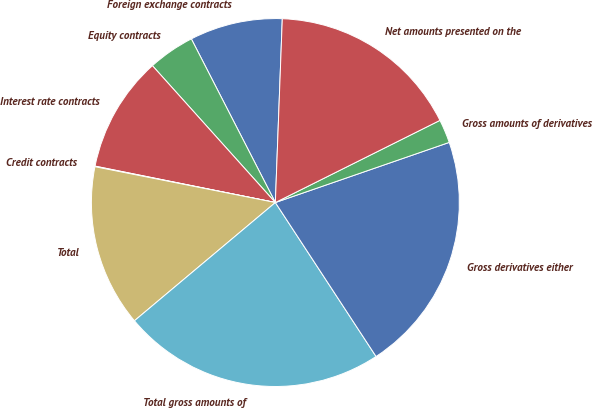Convert chart. <chart><loc_0><loc_0><loc_500><loc_500><pie_chart><fcel>Foreign exchange contracts<fcel>Equity contracts<fcel>Interest rate contracts<fcel>Credit contracts<fcel>Total<fcel>Total gross amounts of<fcel>Gross derivatives either<fcel>Gross amounts of derivatives<fcel>Net amounts presented on the<nl><fcel>8.15%<fcel>4.1%<fcel>10.18%<fcel>0.05%<fcel>14.23%<fcel>23.11%<fcel>21.08%<fcel>2.07%<fcel>17.03%<nl></chart> 